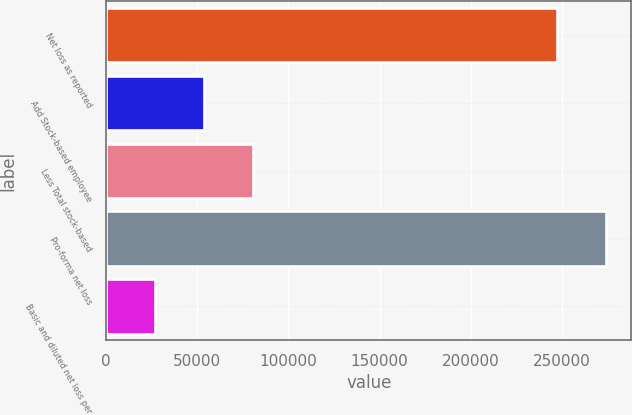Convert chart to OTSL. <chart><loc_0><loc_0><loc_500><loc_500><bar_chart><fcel>Net loss as reported<fcel>Add Stock-based employee<fcel>Less Total stock-based<fcel>Pro-forma net loss<fcel>Basic and diluted net loss per<nl><fcel>247587<fcel>53840.1<fcel>80759.6<fcel>274506<fcel>26920.6<nl></chart> 